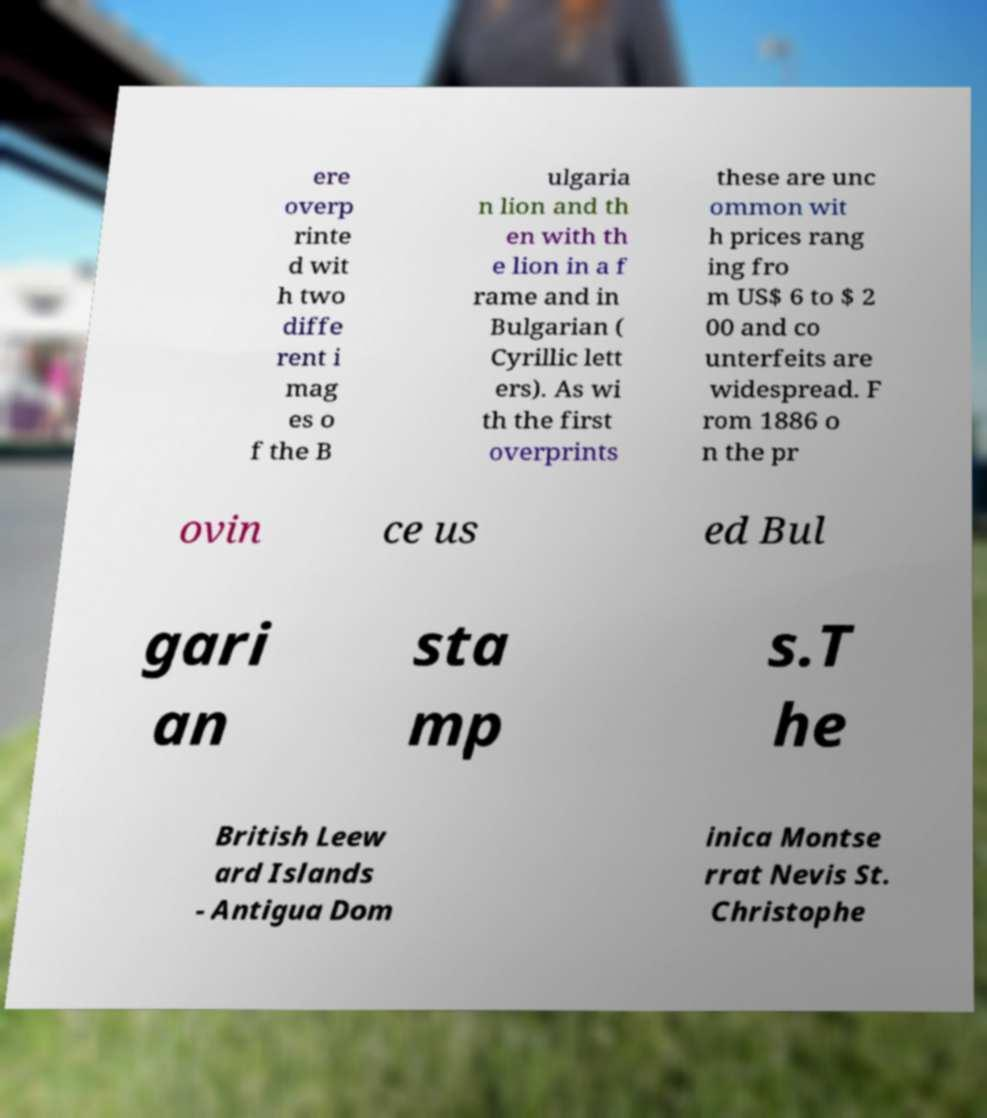Please identify and transcribe the text found in this image. ere overp rinte d wit h two diffe rent i mag es o f the B ulgaria n lion and th en with th e lion in a f rame and in Bulgarian ( Cyrillic lett ers). As wi th the first overprints these are unc ommon wit h prices rang ing fro m US$ 6 to $ 2 00 and co unterfeits are widespread. F rom 1886 o n the pr ovin ce us ed Bul gari an sta mp s.T he British Leew ard Islands - Antigua Dom inica Montse rrat Nevis St. Christophe 